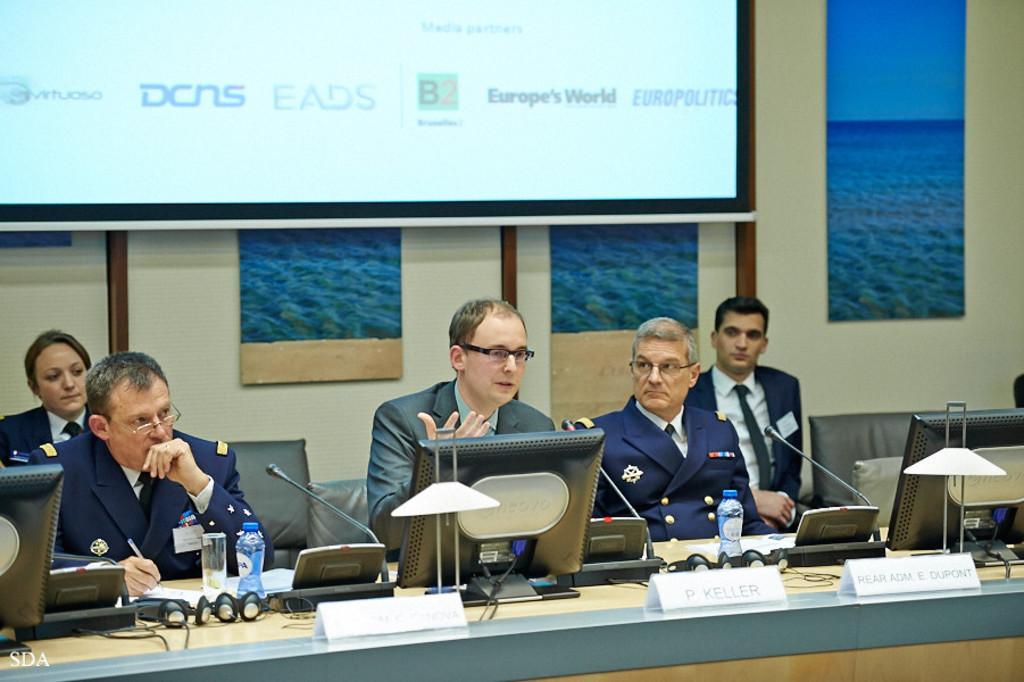Could you give a brief overview of what you see in this image? In this image we can see a few people sitting on the chairs, in front of them, we can see a table, on the table, we can see the name boards, mics, bottles, monitors and some other objects, in the background, we can see some photo frames on the wall, also we can see a screen with some text. 